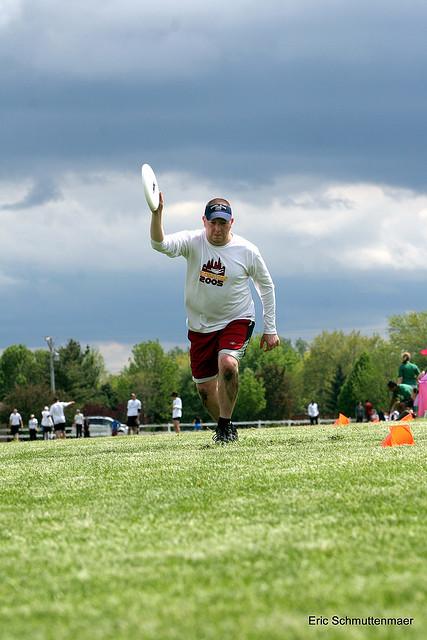What is the man holding?
Answer briefly. Frisbee. How many people are in the picture?
Answer briefly. 11. What color is the man's hat?
Answer briefly. Blue. 